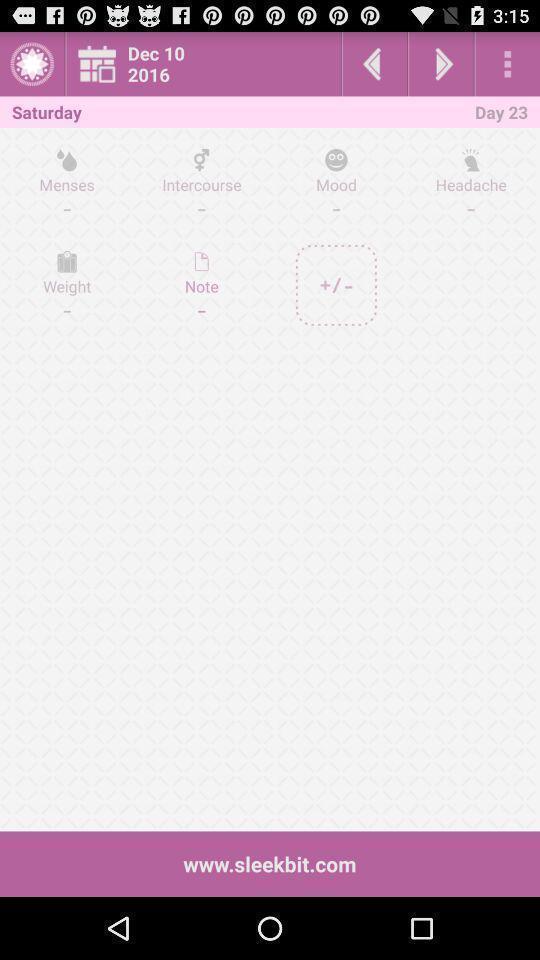What is the overall content of this screenshot? Screen shows multiple options in a health application. 